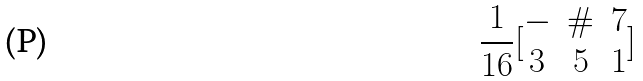Convert formula to latex. <formula><loc_0><loc_0><loc_500><loc_500>\frac { 1 } { 1 6 } [ \begin{matrix} - & \# & 7 \\ 3 & 5 & 1 \end{matrix} ]</formula> 